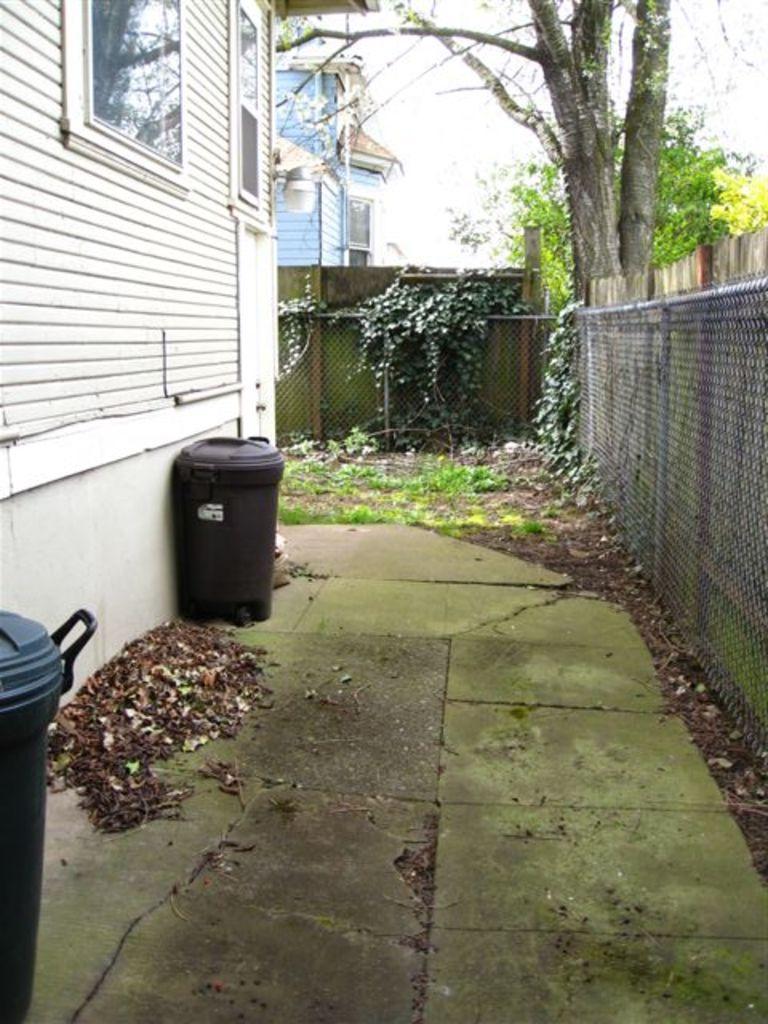Can you describe this image briefly? In this image I can see two bins which are black in color, few leaves on the floor, the metal fencing, the wall, the white colored building, few windows of the building and a tree. In the background I can see few buildings, few trees and the sky. 